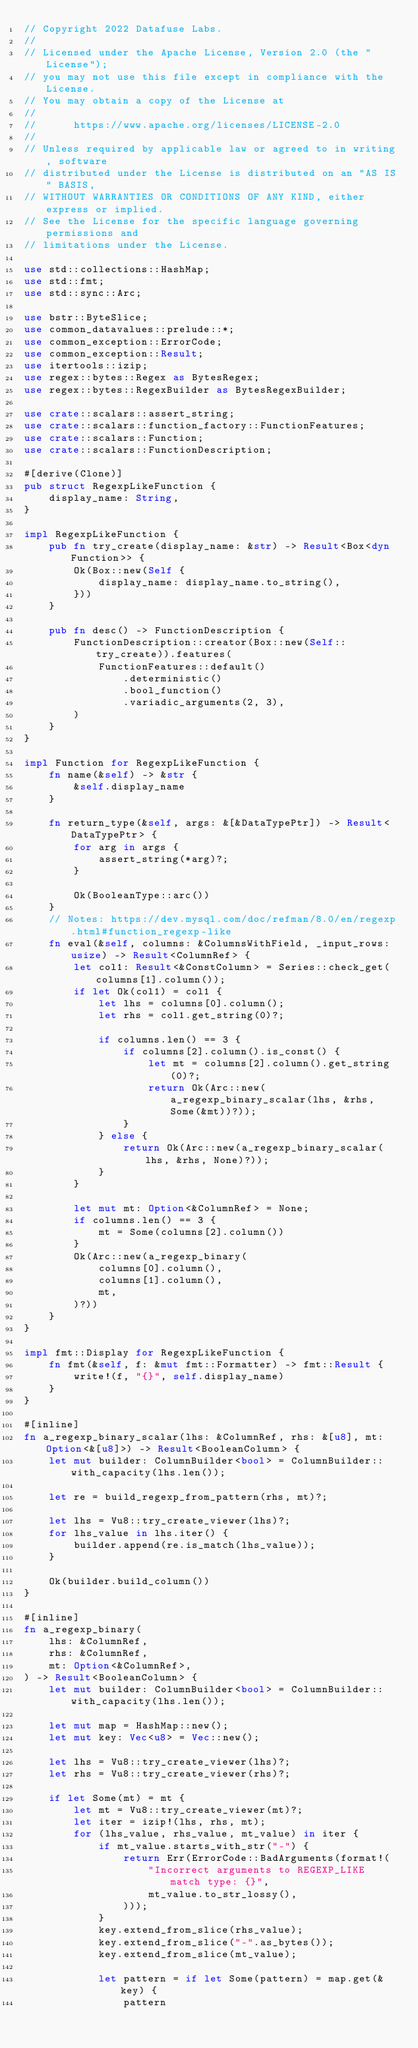Convert code to text. <code><loc_0><loc_0><loc_500><loc_500><_Rust_>// Copyright 2022 Datafuse Labs.
//
// Licensed under the Apache License, Version 2.0 (the "License");
// you may not use this file except in compliance with the License.
// You may obtain a copy of the License at
//
//      https://www.apache.org/licenses/LICENSE-2.0
//
// Unless required by applicable law or agreed to in writing, software
// distributed under the License is distributed on an "AS IS" BASIS,
// WITHOUT WARRANTIES OR CONDITIONS OF ANY KIND, either express or implied.
// See the License for the specific language governing permissions and
// limitations under the License.

use std::collections::HashMap;
use std::fmt;
use std::sync::Arc;

use bstr::ByteSlice;
use common_datavalues::prelude::*;
use common_exception::ErrorCode;
use common_exception::Result;
use itertools::izip;
use regex::bytes::Regex as BytesRegex;
use regex::bytes::RegexBuilder as BytesRegexBuilder;

use crate::scalars::assert_string;
use crate::scalars::function_factory::FunctionFeatures;
use crate::scalars::Function;
use crate::scalars::FunctionDescription;

#[derive(Clone)]
pub struct RegexpLikeFunction {
    display_name: String,
}

impl RegexpLikeFunction {
    pub fn try_create(display_name: &str) -> Result<Box<dyn Function>> {
        Ok(Box::new(Self {
            display_name: display_name.to_string(),
        }))
    }

    pub fn desc() -> FunctionDescription {
        FunctionDescription::creator(Box::new(Self::try_create)).features(
            FunctionFeatures::default()
                .deterministic()
                .bool_function()
                .variadic_arguments(2, 3),
        )
    }
}

impl Function for RegexpLikeFunction {
    fn name(&self) -> &str {
        &self.display_name
    }

    fn return_type(&self, args: &[&DataTypePtr]) -> Result<DataTypePtr> {
        for arg in args {
            assert_string(*arg)?;
        }

        Ok(BooleanType::arc())
    }
    // Notes: https://dev.mysql.com/doc/refman/8.0/en/regexp.html#function_regexp-like
    fn eval(&self, columns: &ColumnsWithField, _input_rows: usize) -> Result<ColumnRef> {
        let col1: Result<&ConstColumn> = Series::check_get(columns[1].column());
        if let Ok(col1) = col1 {
            let lhs = columns[0].column();
            let rhs = col1.get_string(0)?;

            if columns.len() == 3 {
                if columns[2].column().is_const() {
                    let mt = columns[2].column().get_string(0)?;
                    return Ok(Arc::new(a_regexp_binary_scalar(lhs, &rhs, Some(&mt))?));
                }
            } else {
                return Ok(Arc::new(a_regexp_binary_scalar(lhs, &rhs, None)?));
            }
        }

        let mut mt: Option<&ColumnRef> = None;
        if columns.len() == 3 {
            mt = Some(columns[2].column())
        }
        Ok(Arc::new(a_regexp_binary(
            columns[0].column(),
            columns[1].column(),
            mt,
        )?))
    }
}

impl fmt::Display for RegexpLikeFunction {
    fn fmt(&self, f: &mut fmt::Formatter) -> fmt::Result {
        write!(f, "{}", self.display_name)
    }
}

#[inline]
fn a_regexp_binary_scalar(lhs: &ColumnRef, rhs: &[u8], mt: Option<&[u8]>) -> Result<BooleanColumn> {
    let mut builder: ColumnBuilder<bool> = ColumnBuilder::with_capacity(lhs.len());

    let re = build_regexp_from_pattern(rhs, mt)?;

    let lhs = Vu8::try_create_viewer(lhs)?;
    for lhs_value in lhs.iter() {
        builder.append(re.is_match(lhs_value));
    }

    Ok(builder.build_column())
}

#[inline]
fn a_regexp_binary(
    lhs: &ColumnRef,
    rhs: &ColumnRef,
    mt: Option<&ColumnRef>,
) -> Result<BooleanColumn> {
    let mut builder: ColumnBuilder<bool> = ColumnBuilder::with_capacity(lhs.len());

    let mut map = HashMap::new();
    let mut key: Vec<u8> = Vec::new();

    let lhs = Vu8::try_create_viewer(lhs)?;
    let rhs = Vu8::try_create_viewer(rhs)?;

    if let Some(mt) = mt {
        let mt = Vu8::try_create_viewer(mt)?;
        let iter = izip!(lhs, rhs, mt);
        for (lhs_value, rhs_value, mt_value) in iter {
            if mt_value.starts_with_str("-") {
                return Err(ErrorCode::BadArguments(format!(
                    "Incorrect arguments to REGEXP_LIKE match type: {}",
                    mt_value.to_str_lossy(),
                )));
            }
            key.extend_from_slice(rhs_value);
            key.extend_from_slice("-".as_bytes());
            key.extend_from_slice(mt_value);

            let pattern = if let Some(pattern) = map.get(&key) {
                pattern</code> 